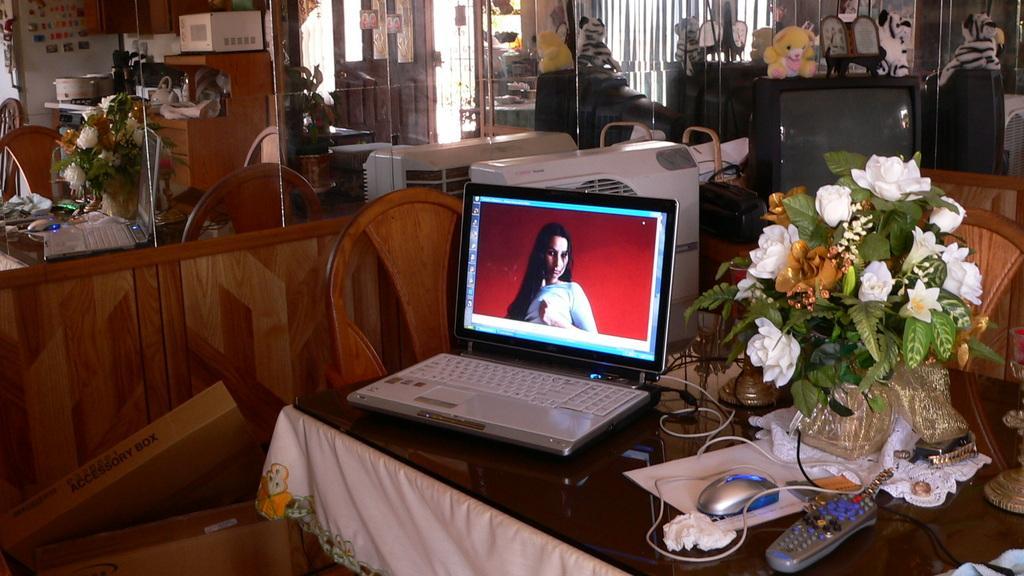Could you give a brief overview of what you see in this image? In this picture we can see a table. On the table there is a laptop, mouse, remote, and a flower vase. Here we can see a television and there is a toy. And this is chair. And here we can see the reflection in the mirror. 